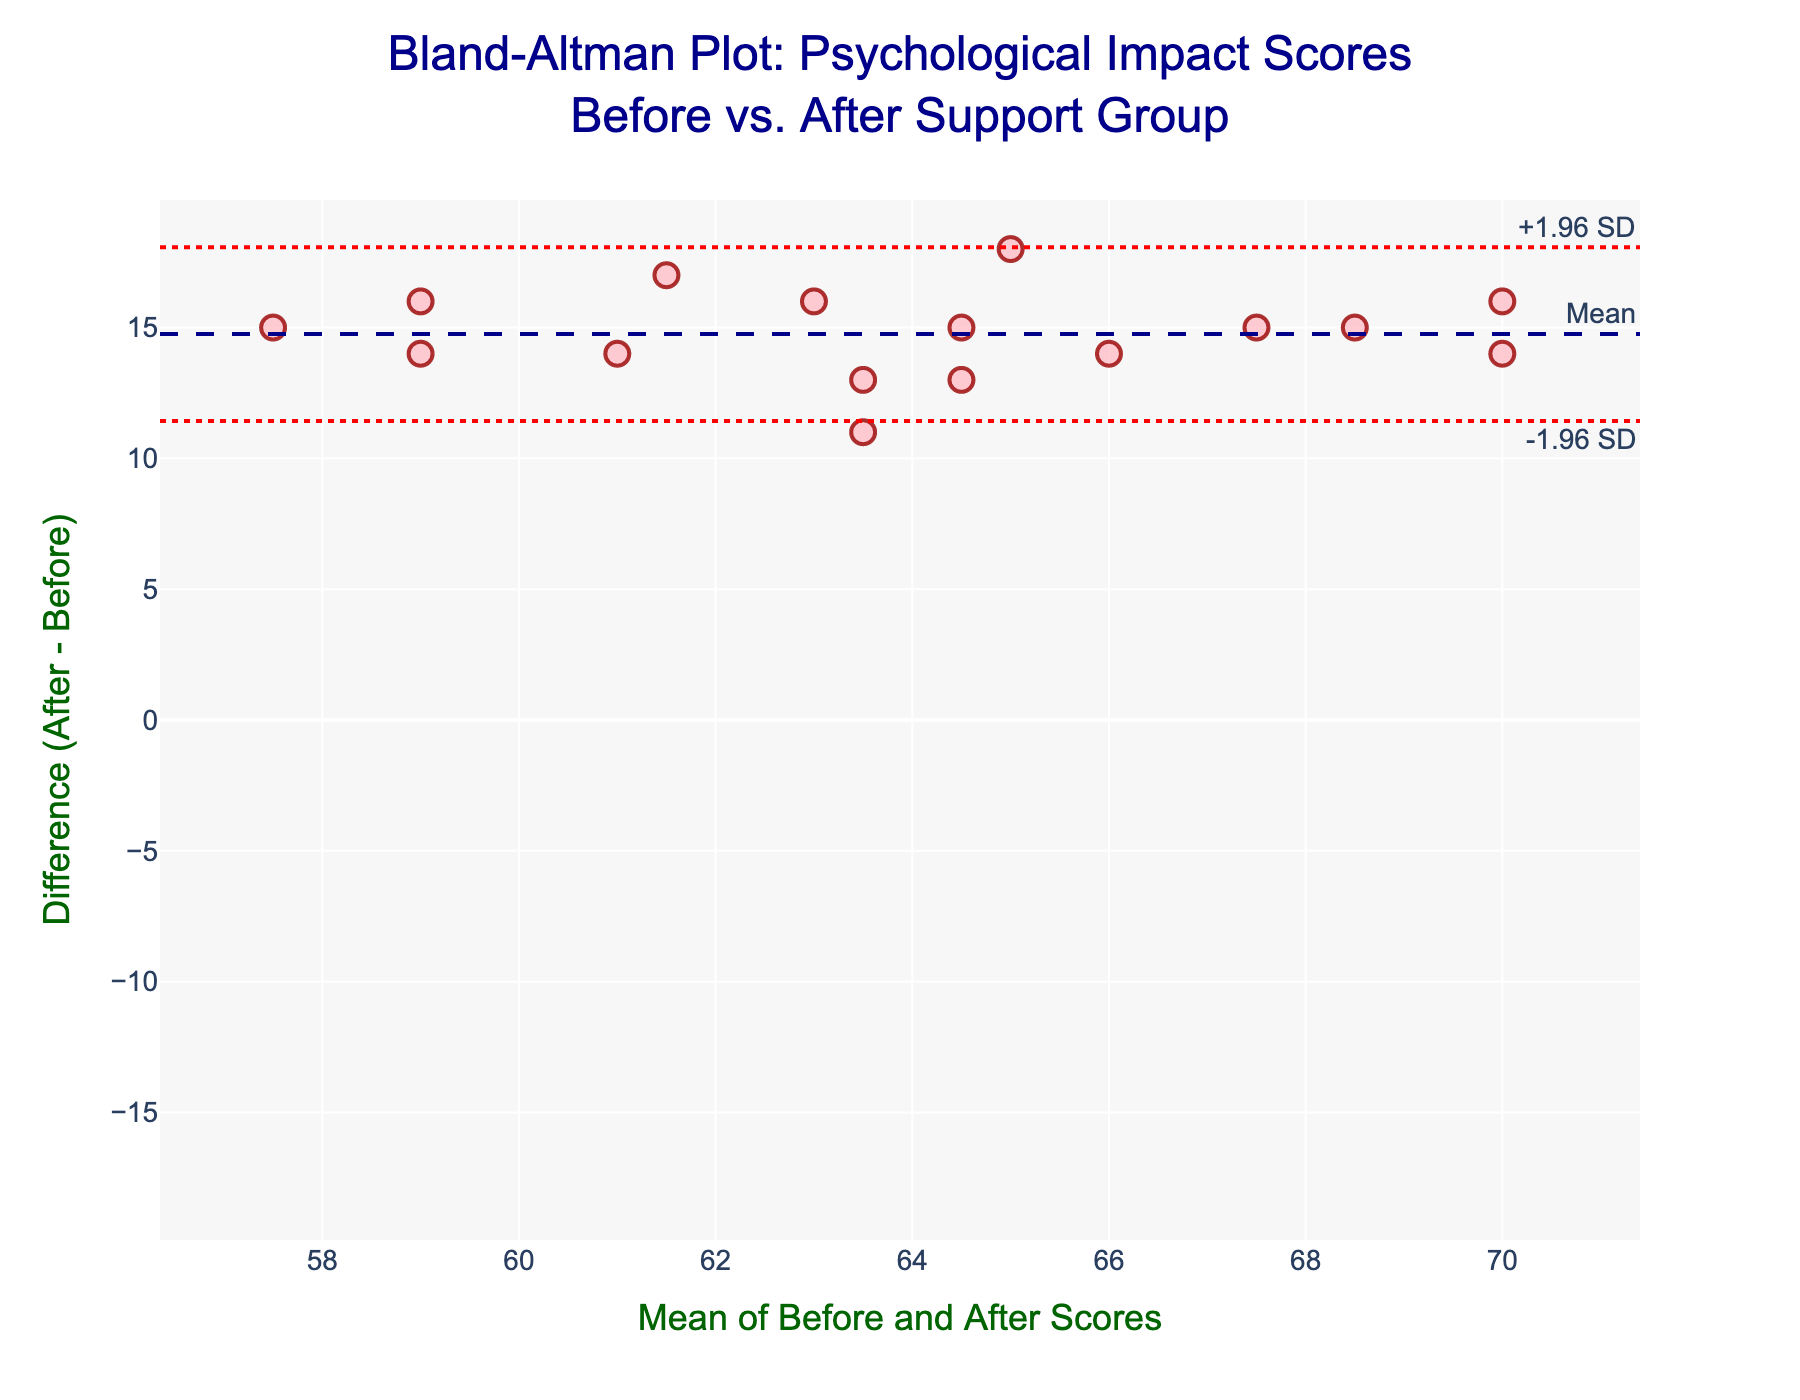What's the title of the figure? The title is usually found at the top of the figure and provides an overview of what the plot represents.
Answer: Bland-Altman Plot: Psychological Impact Scores Before vs. After Support Group What are the labels on the X and Y axes? Axis labels describe what each axis represents, usually found adjacent to the axes.
Answer: X: Mean of Before and After Scores, Y: Difference (After - Before) How many participants' data points are plotted? The figure shows data points as markers. Counting the markers reveals the number of participants.
Answer: 16 What is the mean difference between the scores? The mean difference is indicated by a horizontal dashed line labeled "Mean".
Answer: Approximately 15.06 What are the limits of agreement in the figure? The limits of agreement are shown as dotted lines labeled "+1.96 SD" and "-1.96 SD".
Answer: Approximately 20.99 and 9.13 Which participant has the largest positive difference between before and after scores? Locate the highest point on the Y-axis and identify the corresponding participant.
Answer: John Smith Is there any participant whose before and after scores are nearly equal? Look for data points near the X-axis (where difference is close to zero).
Answer: No What can we infer if a majority of the data points lie within the limits of agreement? This suggests that most participants experience similar psychological impact changes before and after joining the support group.
Answer: Most differences are consistent What participant score pair has a mean closest to 66? Locate the data point on the X-axis near 66 and identify the corresponding participant.
Answer: James Anderson What indicates that joining the support group generally had a positive impact? Points above the zero line on the Y-axis indicate positive changes (higher after scores).
Answer: Most points are above zero 